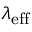Convert formula to latex. <formula><loc_0><loc_0><loc_500><loc_500>\lambda _ { e f f }</formula> 